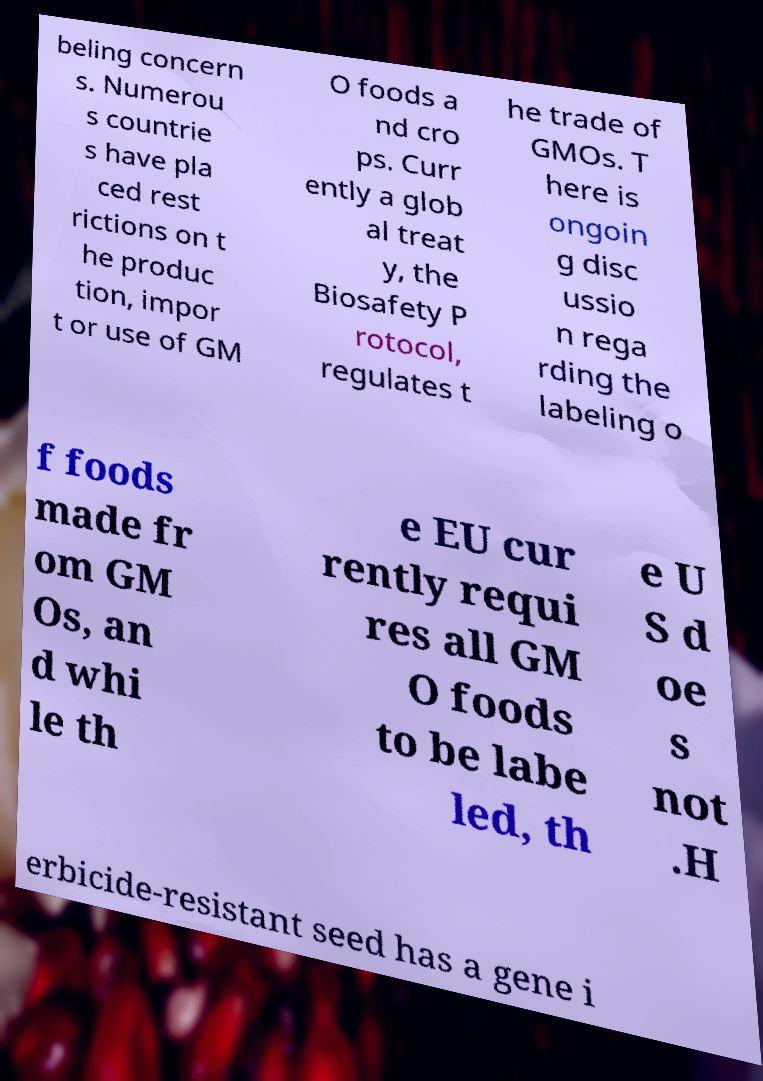Please identify and transcribe the text found in this image. beling concern s. Numerou s countrie s have pla ced rest rictions on t he produc tion, impor t or use of GM O foods a nd cro ps. Curr ently a glob al treat y, the Biosafety P rotocol, regulates t he trade of GMOs. T here is ongoin g disc ussio n rega rding the labeling o f foods made fr om GM Os, an d whi le th e EU cur rently requi res all GM O foods to be labe led, th e U S d oe s not .H erbicide-resistant seed has a gene i 